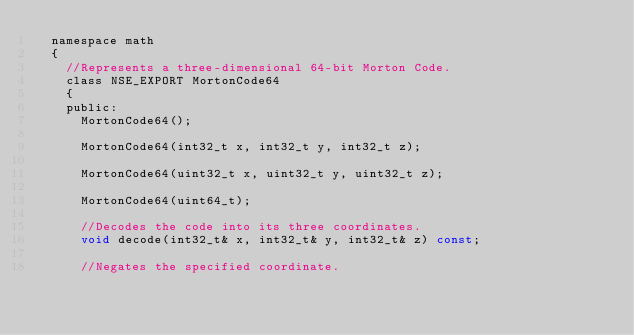<code> <loc_0><loc_0><loc_500><loc_500><_C_>	namespace math
	{
		//Represents a three-dimensional 64-bit Morton Code.
		class NSE_EXPORT MortonCode64
		{
		public:
			MortonCode64();

			MortonCode64(int32_t x, int32_t y, int32_t z);

			MortonCode64(uint32_t x, uint32_t y, uint32_t z);

			MortonCode64(uint64_t);

			//Decodes the code into its three coordinates.
			void decode(int32_t& x, int32_t& y, int32_t& z) const;

			//Negates the specified coordinate.</code> 